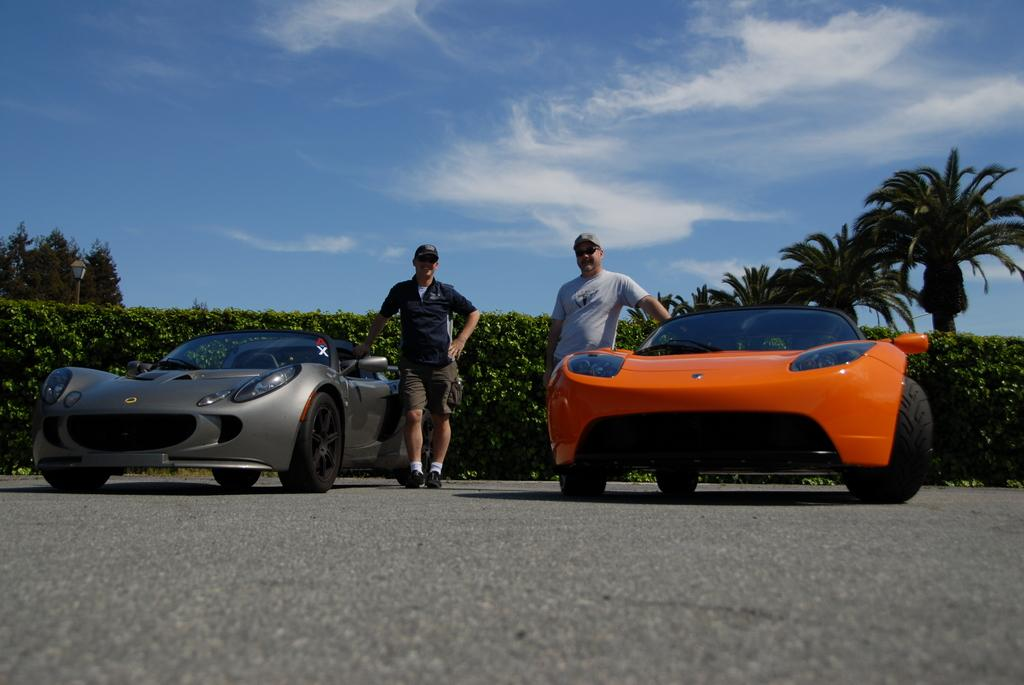What can be seen on the road in the image? There are cars on the road in the image. How many people are present in the image? There are two people standing in the image. What is visible in the background of the image? There are trees and the sky visible in the background of the image. What type of vegetation is present in the image? There is a hedge in the image. Where is the pole located in the image? The pole is on the left side of the image. What type of drink is the person holding in the image? There is no person holding a drink in the image. What thought is the person having in the image? There is no indication of a person's thoughts in the image. 